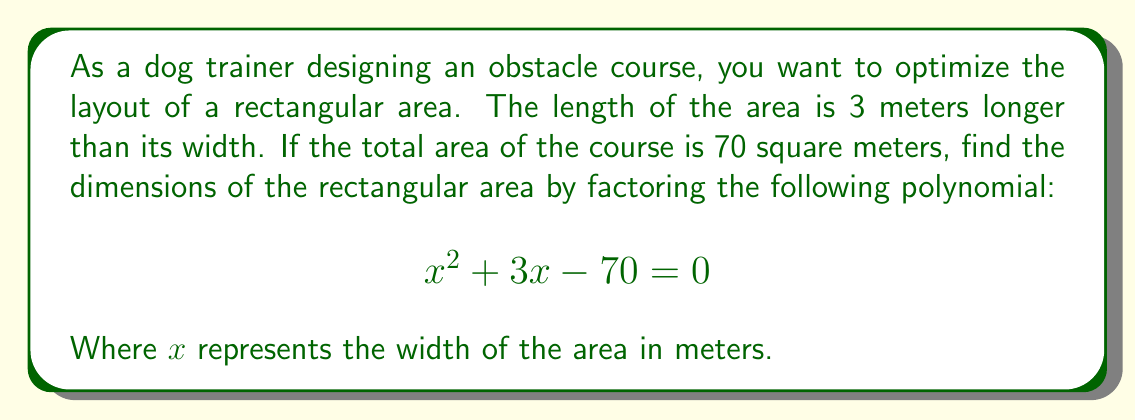Show me your answer to this math problem. Let's approach this step-by-step:

1) We need to factor the polynomial $x^2 + 3x - 70 = 0$

2) This is a quadratic equation in the form $ax^2 + bx + c = 0$, where $a=1$, $b=3$, and $c=-70$

3) To factor this, we need to find two numbers that multiply to give $ac = 1 \times (-70) = -70$ and add up to $b = 3$

4) The numbers that satisfy this are 10 and -7

5) We can rewrite the middle term using these numbers:
   $$x^2 + 10x - 7x - 70 = 0$$

6) Now we can factor by grouping:
   $$(x^2 + 10x) + (-7x - 70) = 0$$
   $$x(x + 10) - 7(x + 10) = 0$$
   $$(x - 7)(x + 10) = 0$$

7) Using the zero product property, we can solve for x:
   $x - 7 = 0$ or $x + 10 = 0$
   $x = 7$ or $x = -10$

8) Since width cannot be negative, we discard the negative solution. Therefore, the width of the area is 7 meters.

9) The length is 3 meters longer than the width, so it's $7 + 3 = 10$ meters.

10) We can verify: $7 \times 10 = 70$ square meters, which matches our given area.
Answer: The dimensions of the rectangular area are 7 meters wide and 10 meters long. 